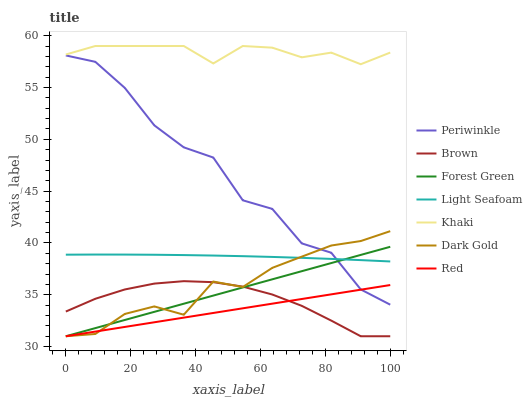Does Red have the minimum area under the curve?
Answer yes or no. Yes. Does Khaki have the maximum area under the curve?
Answer yes or no. Yes. Does Dark Gold have the minimum area under the curve?
Answer yes or no. No. Does Dark Gold have the maximum area under the curve?
Answer yes or no. No. Is Forest Green the smoothest?
Answer yes or no. Yes. Is Periwinkle the roughest?
Answer yes or no. Yes. Is Khaki the smoothest?
Answer yes or no. No. Is Khaki the roughest?
Answer yes or no. No. Does Brown have the lowest value?
Answer yes or no. Yes. Does Khaki have the lowest value?
Answer yes or no. No. Does Khaki have the highest value?
Answer yes or no. Yes. Does Dark Gold have the highest value?
Answer yes or no. No. Is Light Seafoam less than Khaki?
Answer yes or no. Yes. Is Khaki greater than Red?
Answer yes or no. Yes. Does Dark Gold intersect Light Seafoam?
Answer yes or no. Yes. Is Dark Gold less than Light Seafoam?
Answer yes or no. No. Is Dark Gold greater than Light Seafoam?
Answer yes or no. No. Does Light Seafoam intersect Khaki?
Answer yes or no. No. 